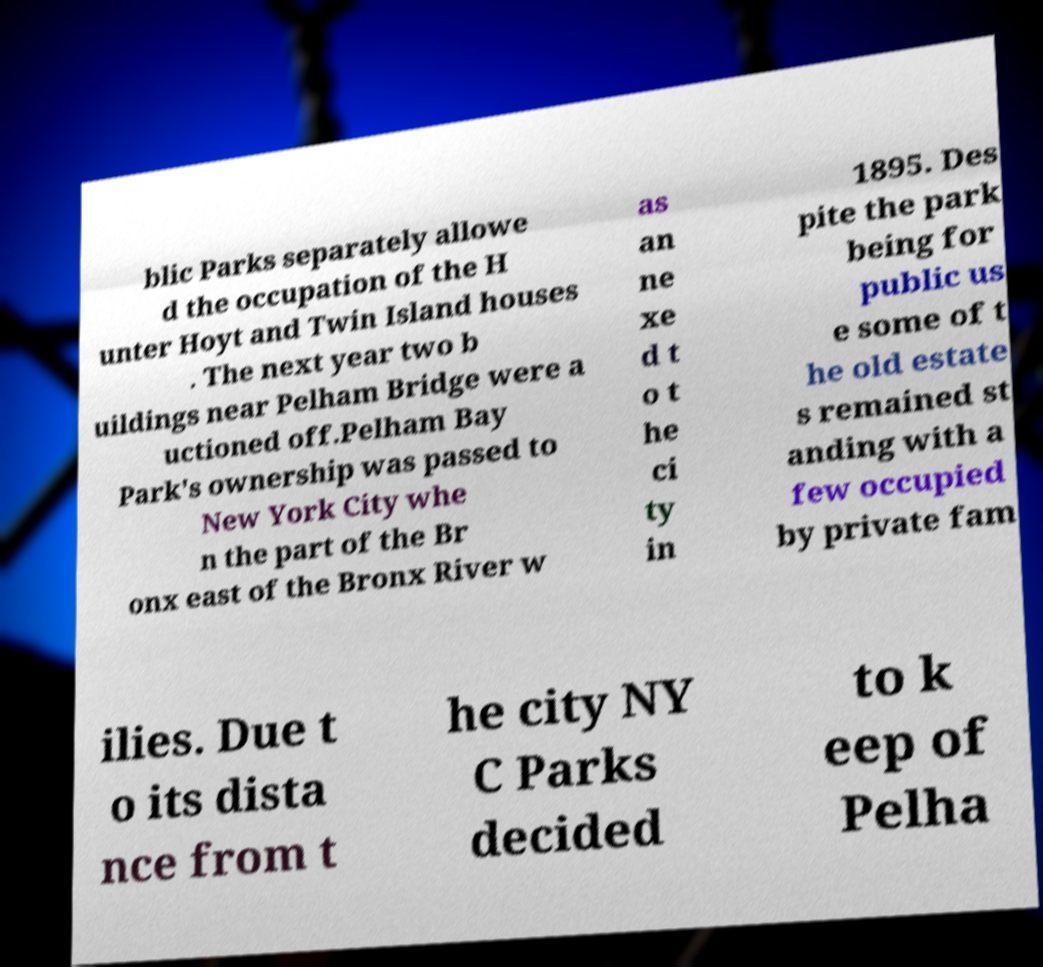I need the written content from this picture converted into text. Can you do that? blic Parks separately allowe d the occupation of the H unter Hoyt and Twin Island houses . The next year two b uildings near Pelham Bridge were a uctioned off.Pelham Bay Park's ownership was passed to New York City whe n the part of the Br onx east of the Bronx River w as an ne xe d t o t he ci ty in 1895. Des pite the park being for public us e some of t he old estate s remained st anding with a few occupied by private fam ilies. Due t o its dista nce from t he city NY C Parks decided to k eep of Pelha 